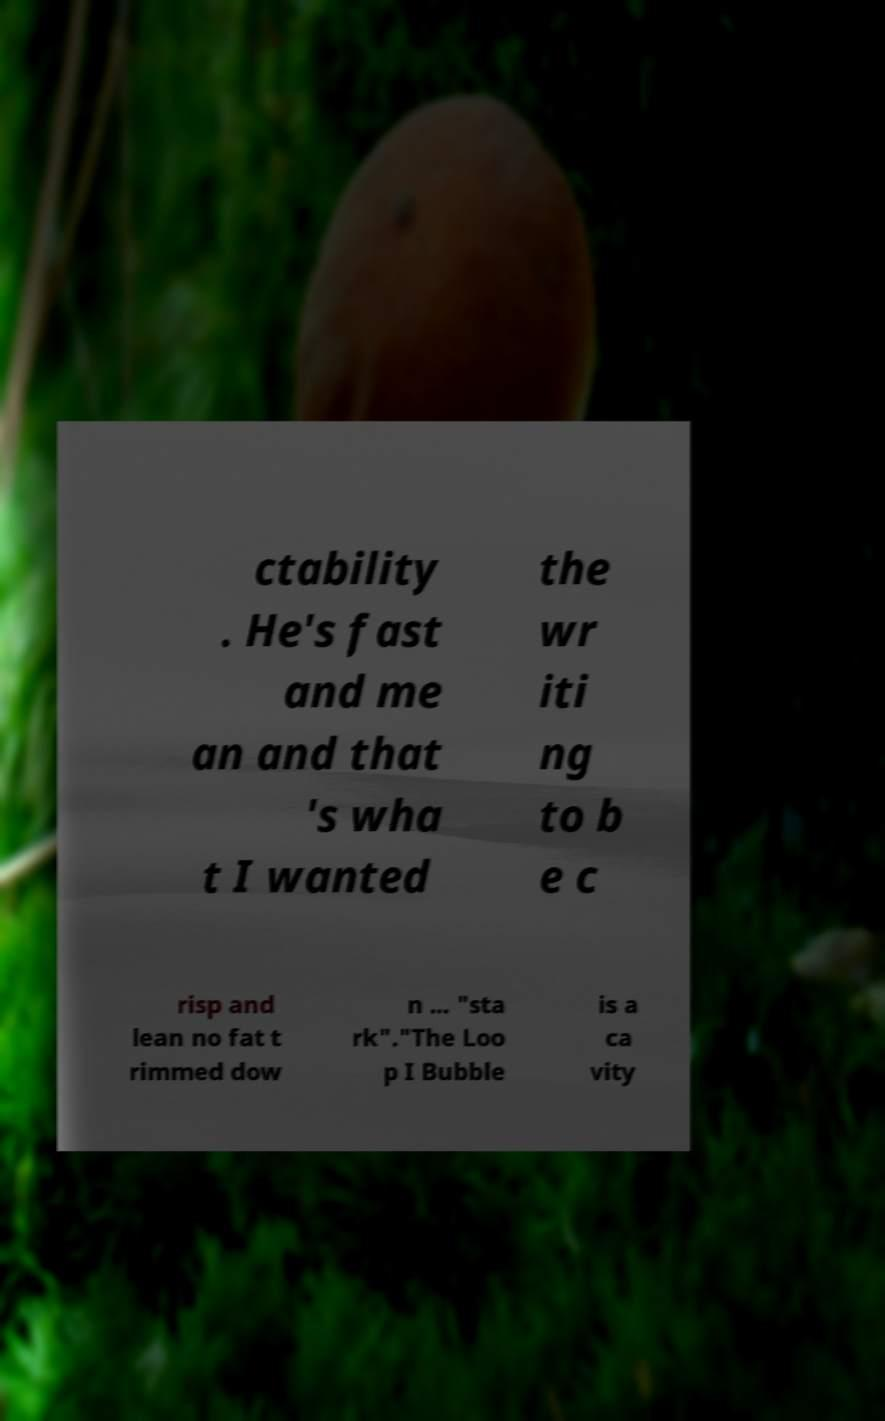Please identify and transcribe the text found in this image. ctability . He's fast and me an and that 's wha t I wanted the wr iti ng to b e c risp and lean no fat t rimmed dow n ... "sta rk"."The Loo p I Bubble is a ca vity 